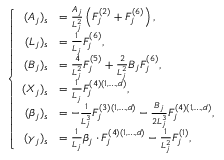Convert formula to latex. <formula><loc_0><loc_0><loc_500><loc_500>\left \{ \begin{array} { r l } { ( A _ { j } ) _ { s } } & { = \frac { A _ { j } } { L _ { j } ^ { 2 } } \left ( F _ { j } ^ { ( 2 ) } + F _ { j } ^ { ( 6 ) } \right ) , } \\ { ( L _ { j } ) _ { s } } & { = \frac { 1 } { L _ { j } } F _ { j } ^ { ( 6 ) } , } \\ { ( B _ { j } ) _ { s } } & { = \frac { 4 } { L _ { j } ^ { 2 } } F _ { j } ^ { ( 5 ) } + \frac { 2 } { L _ { j } ^ { 2 } } B _ { j } F _ { j } ^ { ( 6 ) } , } \\ { ( X _ { j } ) _ { s } } & { = \frac { 1 } { L _ { j } } F _ { j } ^ { ( 4 ) ( 1 , \dots , d ) } , } \\ { ( \beta _ { j } ) _ { s } } & { = - \frac { 1 } { L _ { j } ^ { 3 } } F _ { j } ^ { ( 3 ) ( 1 , \dots , d ) } - \frac { B _ { j } } { 2 L _ { j } ^ { 3 } } F _ { j } ^ { ( 4 ) ( 1 , \dots , d ) } , } \\ { ( \gamma _ { j } ) _ { s } } & { = \frac { 1 } { L _ { j } } \beta _ { j } \cdot F _ { j } ^ { ( 4 ) ( 1 , \dots , d ) } - \frac { 1 } { L _ { j } ^ { 2 } } F _ { j } ^ { ( 1 ) } , } \end{array}</formula> 